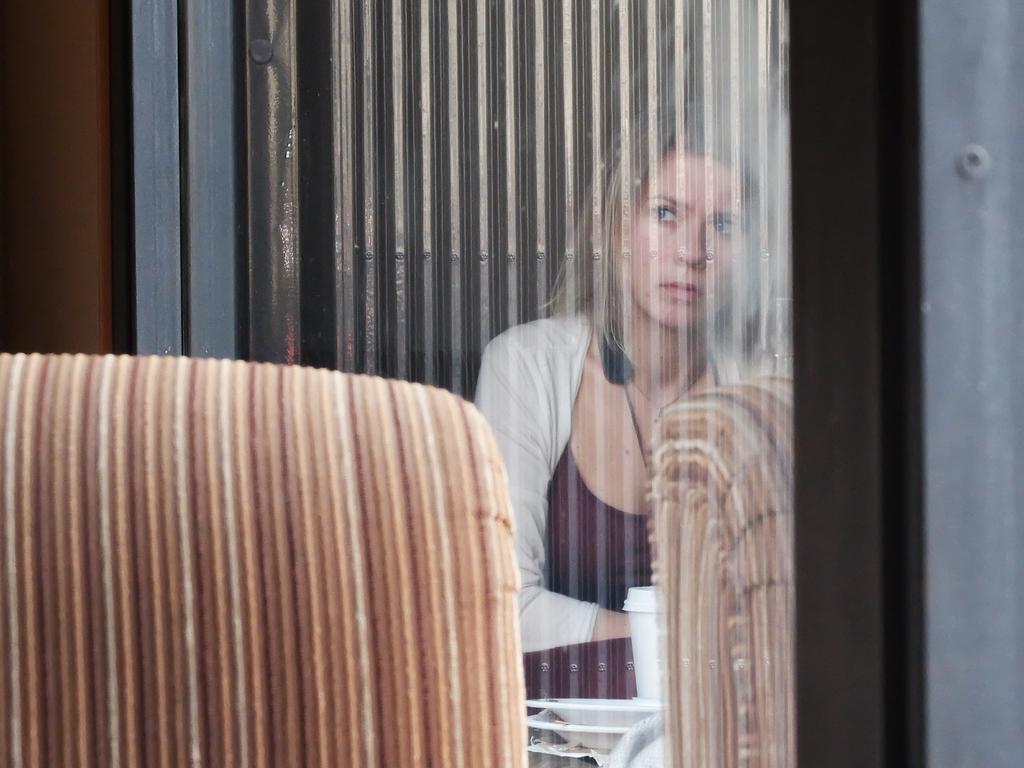Could you give a brief overview of what you see in this image? In this picture I can see reflection of a woman, a cup, few plates and a table in the window glass and looks like a chair on the left side. 